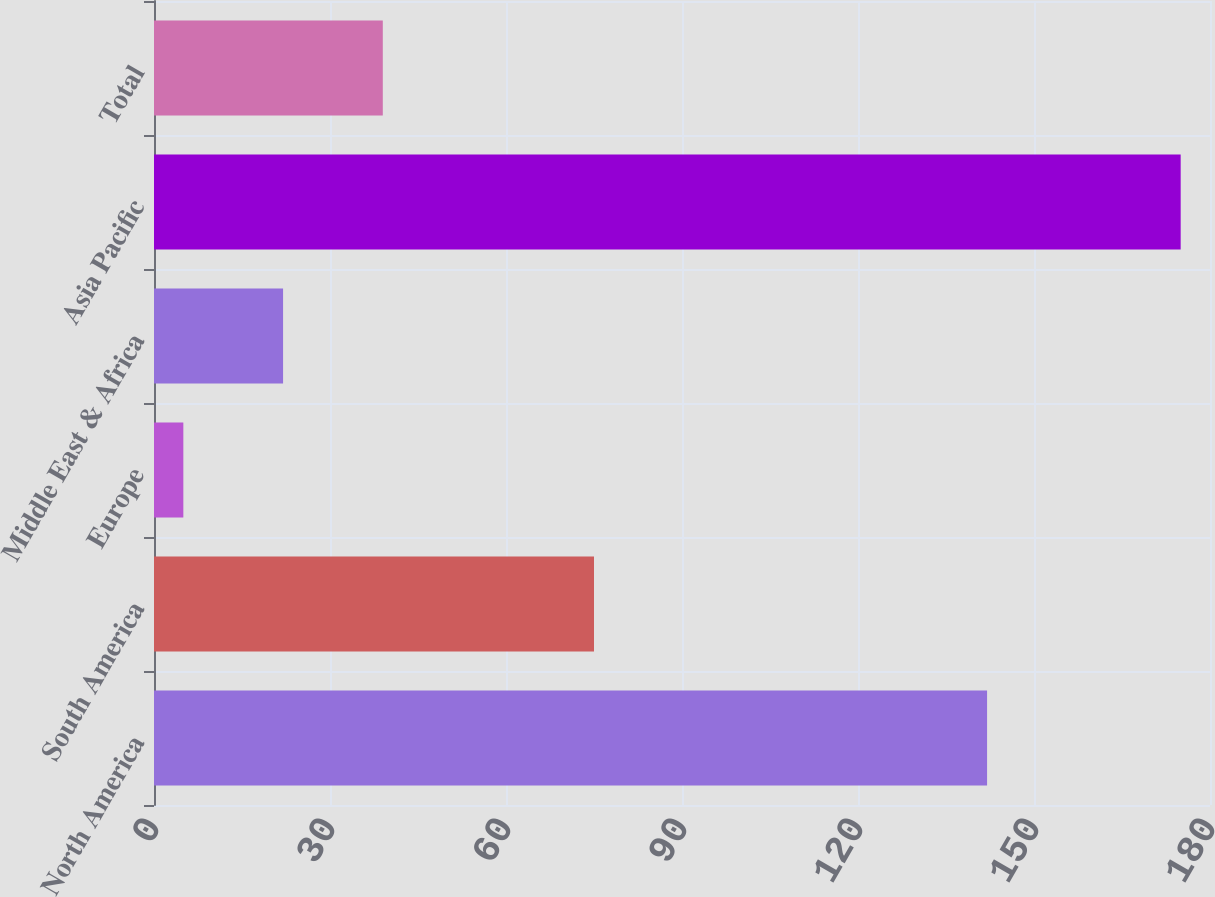Convert chart to OTSL. <chart><loc_0><loc_0><loc_500><loc_500><bar_chart><fcel>North America<fcel>South America<fcel>Europe<fcel>Middle East & Africa<fcel>Asia Pacific<fcel>Total<nl><fcel>142<fcel>75<fcel>5<fcel>22<fcel>175<fcel>39<nl></chart> 